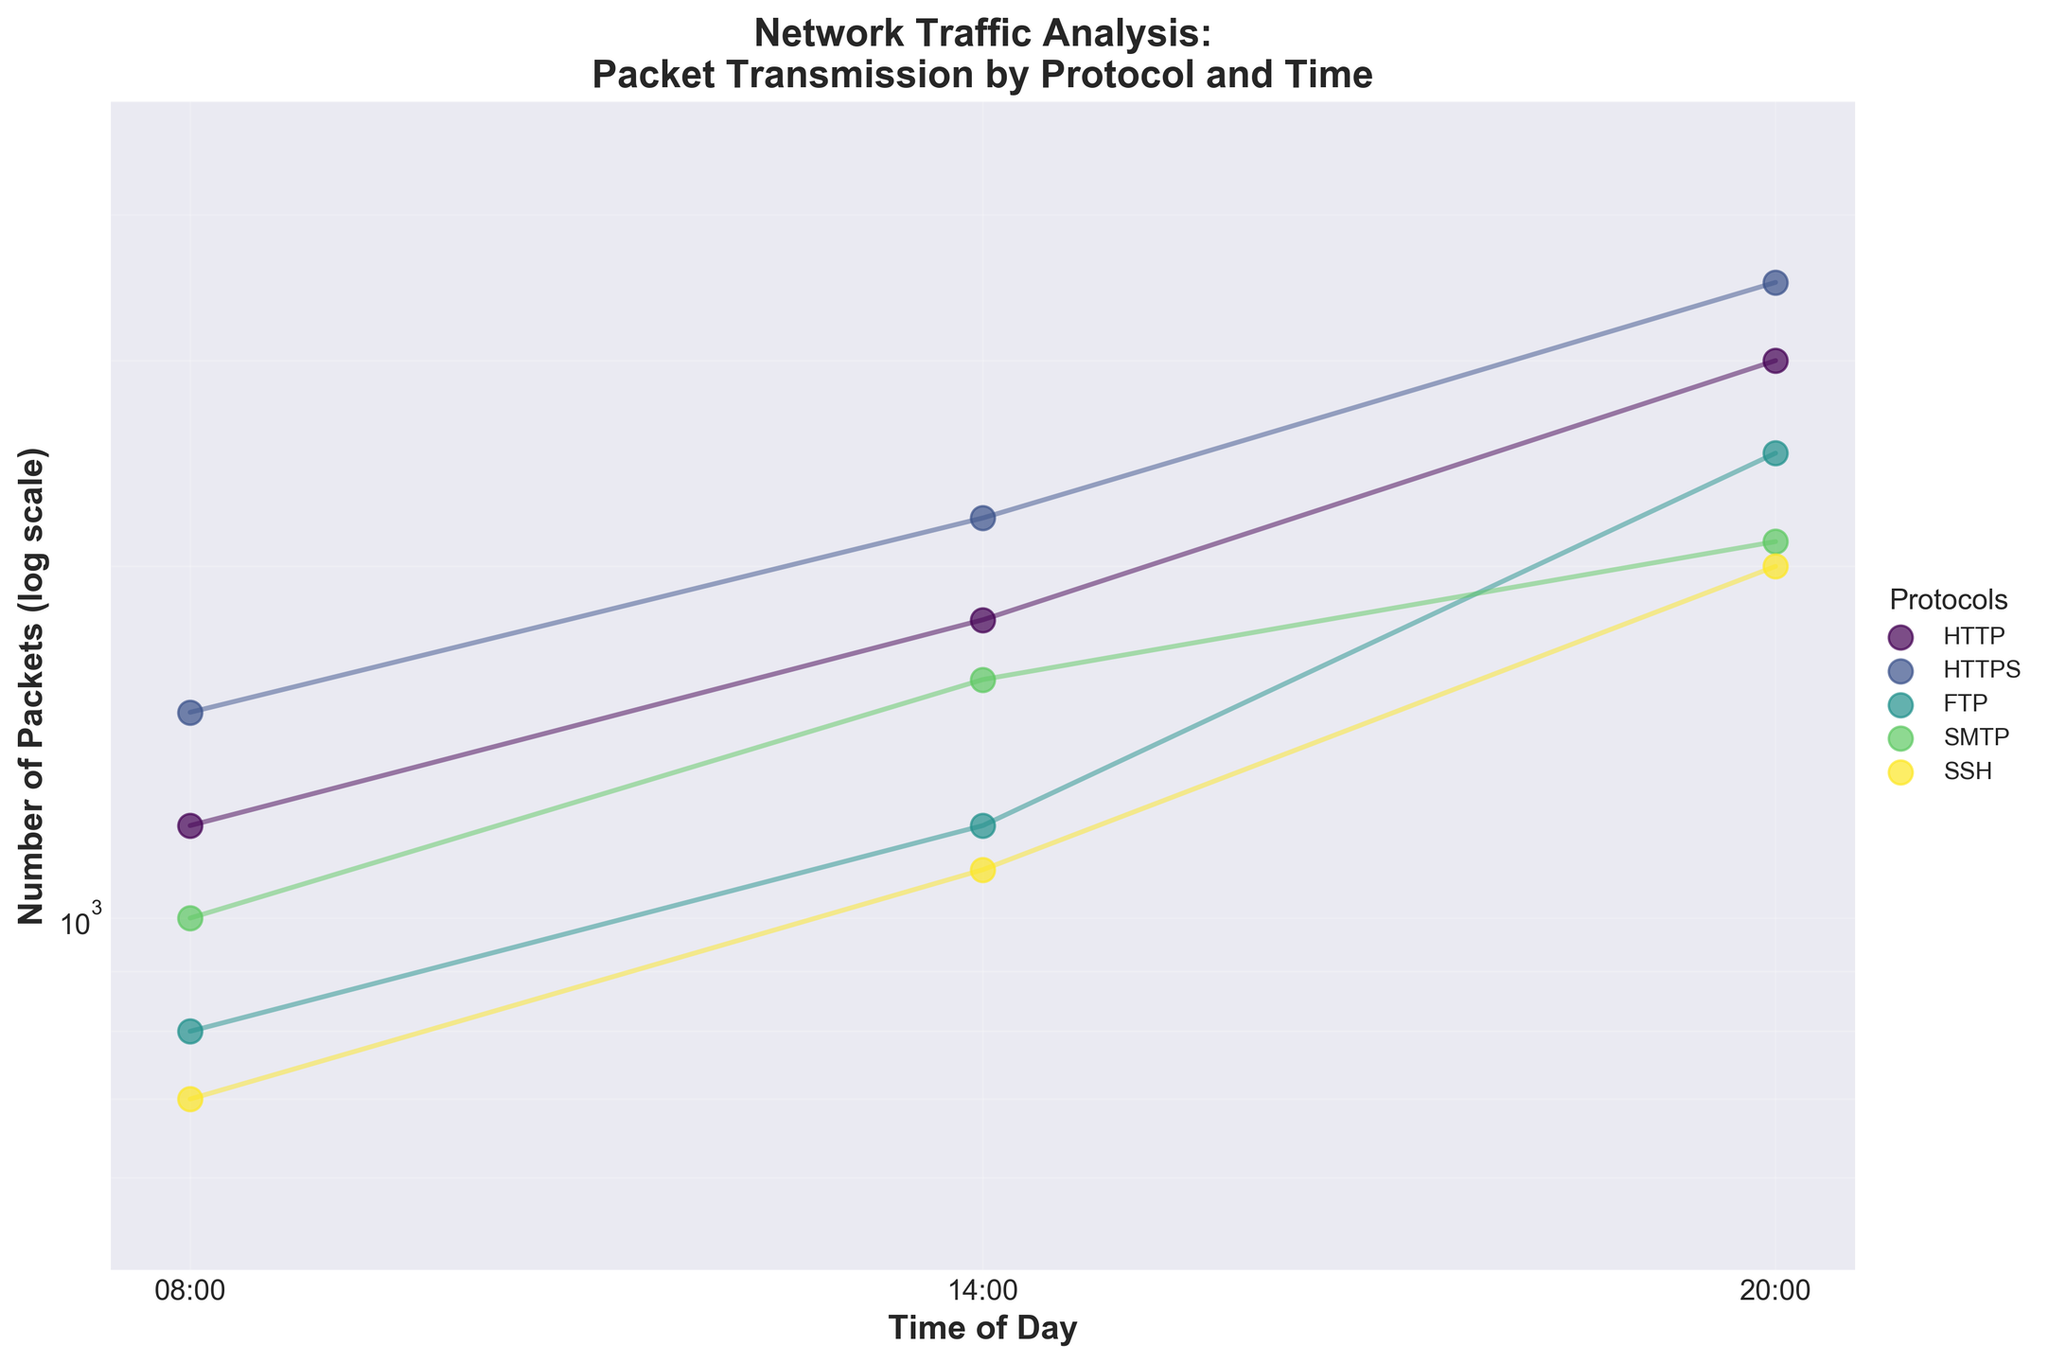What's the title of the plot? The title of the plot is displayed at the top and reads: "Network Traffic Analysis:\nPacket Transmission by Protocol and Time."
Answer: Network Traffic Analysis:\nPacket Transmission by Protocol and Time What is the y-axis scale used in the plot? The y-axis scale is indicated to be logarithmic (log), as noted by the label and the interval spacing of the numbers.
Answer: Log scale At what time is the packet transmission the highest for the HTTP protocol? By observing the HTTP protocol's data points, the highest packet transmission occurs at 20:00.
Answer: 20:00 Which protocol has the fewest transmitted packets at 08:00? By examining the scatter points for each protocol at 08:00, SSH has the fewest transmitted packets at this time.
Answer: SSH What is the difference in the number of packets transmitted by HTTPS between 14:00 and 20:00? From the data, HTTPS transmits 3500 packets at 20:00 and 2200 packets at 14:00. The difference is 3500 - 2200 = 1300.
Answer: 1300 How do the packet numbers for FTP at 20:00 compare to SMTP at the same time? FTP transmits 2500 packets at 20:00 while SMTP transmits 2100 packets. FTP has more packets than SMTP at 20:00.
Answer: FTP transmits more packets than SMTP What would be the average number of packets transmitted by SMTP across all times? The numbers of packets for SMTP at three different times are 1000, 1600, and 2100. The average is (1000 + 1600 + 2100) / 3 = 4700 / 3 ≈ 1567.
Answer: 1567 Across which time interval does HTTP show the largest increase in packet transmission? HTTP's data points are 1200 at 08:00, 1800 at 14:00, and 3000 at 20:00. The largest increase is between 14:00 and 20:00, calculated as 3000 - 1800 = 1200.
Answer: 14:00 to 20:00 Is there any protocol that has consistently increasing packet transmissions over the day? By examining each protocol's points, HTTPS increases at every observed time: 1500 at 08:00, 2200 at 14:00, and 3500 at 20:00.
Answer: HTTPS Which protocol has the steepest increase in transmitted packets from 08:00 to 20:00? Comparing the packet increase from 08:00 to 20:00 for all protocols, HTTPS shows the steepest increase, going from 1500 to 3500 (increase of 2000).
Answer: HTTPS 